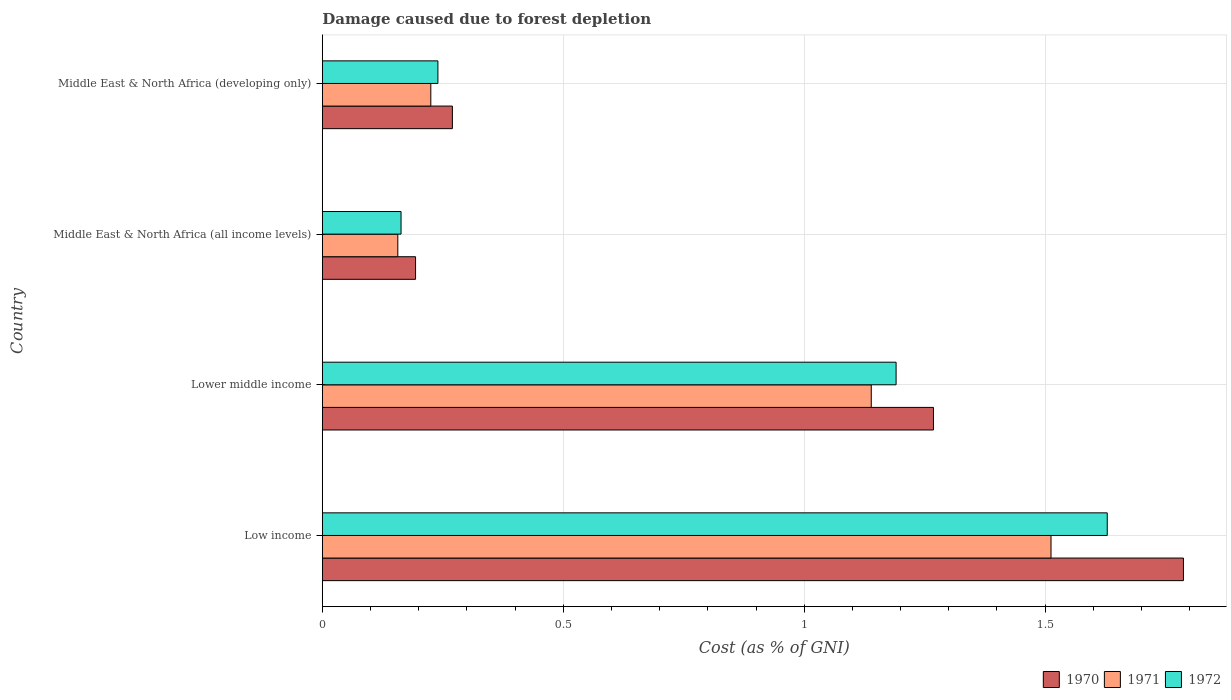How many different coloured bars are there?
Make the answer very short. 3. How many groups of bars are there?
Provide a succinct answer. 4. Are the number of bars on each tick of the Y-axis equal?
Provide a succinct answer. Yes. How many bars are there on the 2nd tick from the top?
Make the answer very short. 3. How many bars are there on the 4th tick from the bottom?
Ensure brevity in your answer.  3. What is the label of the 3rd group of bars from the top?
Give a very brief answer. Lower middle income. What is the cost of damage caused due to forest depletion in 1970 in Middle East & North Africa (developing only)?
Offer a terse response. 0.27. Across all countries, what is the maximum cost of damage caused due to forest depletion in 1971?
Keep it short and to the point. 1.51. Across all countries, what is the minimum cost of damage caused due to forest depletion in 1972?
Provide a short and direct response. 0.16. In which country was the cost of damage caused due to forest depletion in 1971 minimum?
Offer a terse response. Middle East & North Africa (all income levels). What is the total cost of damage caused due to forest depletion in 1972 in the graph?
Offer a very short reply. 3.22. What is the difference between the cost of damage caused due to forest depletion in 1971 in Lower middle income and that in Middle East & North Africa (developing only)?
Give a very brief answer. 0.91. What is the difference between the cost of damage caused due to forest depletion in 1972 in Lower middle income and the cost of damage caused due to forest depletion in 1971 in Middle East & North Africa (all income levels)?
Provide a succinct answer. 1.03. What is the average cost of damage caused due to forest depletion in 1971 per country?
Your answer should be very brief. 0.76. What is the difference between the cost of damage caused due to forest depletion in 1972 and cost of damage caused due to forest depletion in 1970 in Middle East & North Africa (all income levels)?
Ensure brevity in your answer.  -0.03. What is the ratio of the cost of damage caused due to forest depletion in 1970 in Lower middle income to that in Middle East & North Africa (all income levels)?
Offer a terse response. 6.55. Is the difference between the cost of damage caused due to forest depletion in 1972 in Low income and Middle East & North Africa (all income levels) greater than the difference between the cost of damage caused due to forest depletion in 1970 in Low income and Middle East & North Africa (all income levels)?
Keep it short and to the point. No. What is the difference between the highest and the second highest cost of damage caused due to forest depletion in 1972?
Keep it short and to the point. 0.44. What is the difference between the highest and the lowest cost of damage caused due to forest depletion in 1970?
Provide a short and direct response. 1.59. What does the 2nd bar from the bottom in Middle East & North Africa (all income levels) represents?
Provide a succinct answer. 1971. How many bars are there?
Give a very brief answer. 12. Are all the bars in the graph horizontal?
Make the answer very short. Yes. Does the graph contain grids?
Give a very brief answer. Yes. What is the title of the graph?
Provide a succinct answer. Damage caused due to forest depletion. Does "1995" appear as one of the legend labels in the graph?
Your answer should be compact. No. What is the label or title of the X-axis?
Your answer should be compact. Cost (as % of GNI). What is the label or title of the Y-axis?
Keep it short and to the point. Country. What is the Cost (as % of GNI) of 1970 in Low income?
Your response must be concise. 1.79. What is the Cost (as % of GNI) in 1971 in Low income?
Offer a very short reply. 1.51. What is the Cost (as % of GNI) in 1972 in Low income?
Your answer should be compact. 1.63. What is the Cost (as % of GNI) of 1970 in Lower middle income?
Provide a short and direct response. 1.27. What is the Cost (as % of GNI) of 1971 in Lower middle income?
Your answer should be very brief. 1.14. What is the Cost (as % of GNI) of 1972 in Lower middle income?
Ensure brevity in your answer.  1.19. What is the Cost (as % of GNI) in 1970 in Middle East & North Africa (all income levels)?
Provide a short and direct response. 0.19. What is the Cost (as % of GNI) of 1971 in Middle East & North Africa (all income levels)?
Provide a short and direct response. 0.16. What is the Cost (as % of GNI) of 1972 in Middle East & North Africa (all income levels)?
Your response must be concise. 0.16. What is the Cost (as % of GNI) in 1970 in Middle East & North Africa (developing only)?
Provide a succinct answer. 0.27. What is the Cost (as % of GNI) in 1971 in Middle East & North Africa (developing only)?
Give a very brief answer. 0.23. What is the Cost (as % of GNI) in 1972 in Middle East & North Africa (developing only)?
Your answer should be very brief. 0.24. Across all countries, what is the maximum Cost (as % of GNI) of 1970?
Offer a terse response. 1.79. Across all countries, what is the maximum Cost (as % of GNI) in 1971?
Your response must be concise. 1.51. Across all countries, what is the maximum Cost (as % of GNI) of 1972?
Ensure brevity in your answer.  1.63. Across all countries, what is the minimum Cost (as % of GNI) of 1970?
Provide a short and direct response. 0.19. Across all countries, what is the minimum Cost (as % of GNI) of 1971?
Your answer should be compact. 0.16. Across all countries, what is the minimum Cost (as % of GNI) of 1972?
Ensure brevity in your answer.  0.16. What is the total Cost (as % of GNI) of 1970 in the graph?
Keep it short and to the point. 3.52. What is the total Cost (as % of GNI) of 1971 in the graph?
Offer a terse response. 3.03. What is the total Cost (as % of GNI) of 1972 in the graph?
Your answer should be compact. 3.22. What is the difference between the Cost (as % of GNI) of 1970 in Low income and that in Lower middle income?
Provide a succinct answer. 0.52. What is the difference between the Cost (as % of GNI) of 1971 in Low income and that in Lower middle income?
Ensure brevity in your answer.  0.37. What is the difference between the Cost (as % of GNI) in 1972 in Low income and that in Lower middle income?
Your answer should be compact. 0.44. What is the difference between the Cost (as % of GNI) in 1970 in Low income and that in Middle East & North Africa (all income levels)?
Keep it short and to the point. 1.59. What is the difference between the Cost (as % of GNI) of 1971 in Low income and that in Middle East & North Africa (all income levels)?
Keep it short and to the point. 1.36. What is the difference between the Cost (as % of GNI) of 1972 in Low income and that in Middle East & North Africa (all income levels)?
Give a very brief answer. 1.47. What is the difference between the Cost (as % of GNI) of 1970 in Low income and that in Middle East & North Africa (developing only)?
Your answer should be very brief. 1.52. What is the difference between the Cost (as % of GNI) of 1971 in Low income and that in Middle East & North Africa (developing only)?
Your answer should be very brief. 1.29. What is the difference between the Cost (as % of GNI) in 1972 in Low income and that in Middle East & North Africa (developing only)?
Your answer should be very brief. 1.39. What is the difference between the Cost (as % of GNI) in 1970 in Lower middle income and that in Middle East & North Africa (all income levels)?
Provide a succinct answer. 1.07. What is the difference between the Cost (as % of GNI) in 1971 in Lower middle income and that in Middle East & North Africa (all income levels)?
Ensure brevity in your answer.  0.98. What is the difference between the Cost (as % of GNI) in 1972 in Lower middle income and that in Middle East & North Africa (all income levels)?
Provide a short and direct response. 1.03. What is the difference between the Cost (as % of GNI) in 1970 in Lower middle income and that in Middle East & North Africa (developing only)?
Your answer should be compact. 1. What is the difference between the Cost (as % of GNI) in 1971 in Lower middle income and that in Middle East & North Africa (developing only)?
Your answer should be very brief. 0.91. What is the difference between the Cost (as % of GNI) of 1972 in Lower middle income and that in Middle East & North Africa (developing only)?
Offer a terse response. 0.95. What is the difference between the Cost (as % of GNI) in 1970 in Middle East & North Africa (all income levels) and that in Middle East & North Africa (developing only)?
Offer a terse response. -0.08. What is the difference between the Cost (as % of GNI) of 1971 in Middle East & North Africa (all income levels) and that in Middle East & North Africa (developing only)?
Offer a very short reply. -0.07. What is the difference between the Cost (as % of GNI) in 1972 in Middle East & North Africa (all income levels) and that in Middle East & North Africa (developing only)?
Your answer should be compact. -0.08. What is the difference between the Cost (as % of GNI) in 1970 in Low income and the Cost (as % of GNI) in 1971 in Lower middle income?
Give a very brief answer. 0.65. What is the difference between the Cost (as % of GNI) of 1970 in Low income and the Cost (as % of GNI) of 1972 in Lower middle income?
Your answer should be compact. 0.6. What is the difference between the Cost (as % of GNI) of 1971 in Low income and the Cost (as % of GNI) of 1972 in Lower middle income?
Your answer should be very brief. 0.32. What is the difference between the Cost (as % of GNI) of 1970 in Low income and the Cost (as % of GNI) of 1971 in Middle East & North Africa (all income levels)?
Offer a very short reply. 1.63. What is the difference between the Cost (as % of GNI) of 1970 in Low income and the Cost (as % of GNI) of 1972 in Middle East & North Africa (all income levels)?
Give a very brief answer. 1.62. What is the difference between the Cost (as % of GNI) of 1971 in Low income and the Cost (as % of GNI) of 1972 in Middle East & North Africa (all income levels)?
Keep it short and to the point. 1.35. What is the difference between the Cost (as % of GNI) in 1970 in Low income and the Cost (as % of GNI) in 1971 in Middle East & North Africa (developing only)?
Your answer should be compact. 1.56. What is the difference between the Cost (as % of GNI) in 1970 in Low income and the Cost (as % of GNI) in 1972 in Middle East & North Africa (developing only)?
Offer a terse response. 1.55. What is the difference between the Cost (as % of GNI) of 1971 in Low income and the Cost (as % of GNI) of 1972 in Middle East & North Africa (developing only)?
Provide a short and direct response. 1.27. What is the difference between the Cost (as % of GNI) of 1970 in Lower middle income and the Cost (as % of GNI) of 1971 in Middle East & North Africa (all income levels)?
Provide a succinct answer. 1.11. What is the difference between the Cost (as % of GNI) in 1970 in Lower middle income and the Cost (as % of GNI) in 1972 in Middle East & North Africa (all income levels)?
Offer a terse response. 1.1. What is the difference between the Cost (as % of GNI) of 1971 in Lower middle income and the Cost (as % of GNI) of 1972 in Middle East & North Africa (all income levels)?
Give a very brief answer. 0.98. What is the difference between the Cost (as % of GNI) of 1970 in Lower middle income and the Cost (as % of GNI) of 1971 in Middle East & North Africa (developing only)?
Give a very brief answer. 1.04. What is the difference between the Cost (as % of GNI) of 1970 in Lower middle income and the Cost (as % of GNI) of 1972 in Middle East & North Africa (developing only)?
Give a very brief answer. 1.03. What is the difference between the Cost (as % of GNI) of 1971 in Lower middle income and the Cost (as % of GNI) of 1972 in Middle East & North Africa (developing only)?
Your answer should be very brief. 0.9. What is the difference between the Cost (as % of GNI) of 1970 in Middle East & North Africa (all income levels) and the Cost (as % of GNI) of 1971 in Middle East & North Africa (developing only)?
Make the answer very short. -0.03. What is the difference between the Cost (as % of GNI) of 1970 in Middle East & North Africa (all income levels) and the Cost (as % of GNI) of 1972 in Middle East & North Africa (developing only)?
Give a very brief answer. -0.05. What is the difference between the Cost (as % of GNI) of 1971 in Middle East & North Africa (all income levels) and the Cost (as % of GNI) of 1972 in Middle East & North Africa (developing only)?
Make the answer very short. -0.08. What is the average Cost (as % of GNI) of 1970 per country?
Ensure brevity in your answer.  0.88. What is the average Cost (as % of GNI) of 1971 per country?
Offer a terse response. 0.76. What is the average Cost (as % of GNI) in 1972 per country?
Offer a very short reply. 0.81. What is the difference between the Cost (as % of GNI) of 1970 and Cost (as % of GNI) of 1971 in Low income?
Your response must be concise. 0.27. What is the difference between the Cost (as % of GNI) of 1970 and Cost (as % of GNI) of 1972 in Low income?
Offer a very short reply. 0.16. What is the difference between the Cost (as % of GNI) of 1971 and Cost (as % of GNI) of 1972 in Low income?
Your response must be concise. -0.12. What is the difference between the Cost (as % of GNI) of 1970 and Cost (as % of GNI) of 1971 in Lower middle income?
Keep it short and to the point. 0.13. What is the difference between the Cost (as % of GNI) of 1970 and Cost (as % of GNI) of 1972 in Lower middle income?
Offer a terse response. 0.08. What is the difference between the Cost (as % of GNI) in 1971 and Cost (as % of GNI) in 1972 in Lower middle income?
Make the answer very short. -0.05. What is the difference between the Cost (as % of GNI) of 1970 and Cost (as % of GNI) of 1971 in Middle East & North Africa (all income levels)?
Your answer should be very brief. 0.04. What is the difference between the Cost (as % of GNI) of 1970 and Cost (as % of GNI) of 1972 in Middle East & North Africa (all income levels)?
Ensure brevity in your answer.  0.03. What is the difference between the Cost (as % of GNI) of 1971 and Cost (as % of GNI) of 1972 in Middle East & North Africa (all income levels)?
Provide a succinct answer. -0.01. What is the difference between the Cost (as % of GNI) in 1970 and Cost (as % of GNI) in 1971 in Middle East & North Africa (developing only)?
Your response must be concise. 0.04. What is the difference between the Cost (as % of GNI) of 1970 and Cost (as % of GNI) of 1972 in Middle East & North Africa (developing only)?
Offer a terse response. 0.03. What is the difference between the Cost (as % of GNI) of 1971 and Cost (as % of GNI) of 1972 in Middle East & North Africa (developing only)?
Keep it short and to the point. -0.01. What is the ratio of the Cost (as % of GNI) in 1970 in Low income to that in Lower middle income?
Your answer should be compact. 1.41. What is the ratio of the Cost (as % of GNI) in 1971 in Low income to that in Lower middle income?
Your response must be concise. 1.33. What is the ratio of the Cost (as % of GNI) of 1972 in Low income to that in Lower middle income?
Provide a succinct answer. 1.37. What is the ratio of the Cost (as % of GNI) of 1970 in Low income to that in Middle East & North Africa (all income levels)?
Provide a succinct answer. 9.24. What is the ratio of the Cost (as % of GNI) in 1971 in Low income to that in Middle East & North Africa (all income levels)?
Your answer should be compact. 9.65. What is the ratio of the Cost (as % of GNI) in 1972 in Low income to that in Middle East & North Africa (all income levels)?
Provide a short and direct response. 9.97. What is the ratio of the Cost (as % of GNI) in 1970 in Low income to that in Middle East & North Africa (developing only)?
Provide a short and direct response. 6.62. What is the ratio of the Cost (as % of GNI) in 1971 in Low income to that in Middle East & North Africa (developing only)?
Offer a very short reply. 6.72. What is the ratio of the Cost (as % of GNI) in 1972 in Low income to that in Middle East & North Africa (developing only)?
Offer a terse response. 6.79. What is the ratio of the Cost (as % of GNI) in 1970 in Lower middle income to that in Middle East & North Africa (all income levels)?
Ensure brevity in your answer.  6.55. What is the ratio of the Cost (as % of GNI) of 1971 in Lower middle income to that in Middle East & North Africa (all income levels)?
Give a very brief answer. 7.27. What is the ratio of the Cost (as % of GNI) of 1972 in Lower middle income to that in Middle East & North Africa (all income levels)?
Offer a terse response. 7.29. What is the ratio of the Cost (as % of GNI) of 1970 in Lower middle income to that in Middle East & North Africa (developing only)?
Make the answer very short. 4.7. What is the ratio of the Cost (as % of GNI) of 1971 in Lower middle income to that in Middle East & North Africa (developing only)?
Your answer should be very brief. 5.06. What is the ratio of the Cost (as % of GNI) in 1972 in Lower middle income to that in Middle East & North Africa (developing only)?
Offer a terse response. 4.96. What is the ratio of the Cost (as % of GNI) of 1970 in Middle East & North Africa (all income levels) to that in Middle East & North Africa (developing only)?
Offer a terse response. 0.72. What is the ratio of the Cost (as % of GNI) of 1971 in Middle East & North Africa (all income levels) to that in Middle East & North Africa (developing only)?
Make the answer very short. 0.7. What is the ratio of the Cost (as % of GNI) of 1972 in Middle East & North Africa (all income levels) to that in Middle East & North Africa (developing only)?
Your answer should be compact. 0.68. What is the difference between the highest and the second highest Cost (as % of GNI) of 1970?
Keep it short and to the point. 0.52. What is the difference between the highest and the second highest Cost (as % of GNI) in 1971?
Give a very brief answer. 0.37. What is the difference between the highest and the second highest Cost (as % of GNI) of 1972?
Provide a succinct answer. 0.44. What is the difference between the highest and the lowest Cost (as % of GNI) of 1970?
Offer a very short reply. 1.59. What is the difference between the highest and the lowest Cost (as % of GNI) of 1971?
Offer a very short reply. 1.36. What is the difference between the highest and the lowest Cost (as % of GNI) in 1972?
Provide a short and direct response. 1.47. 